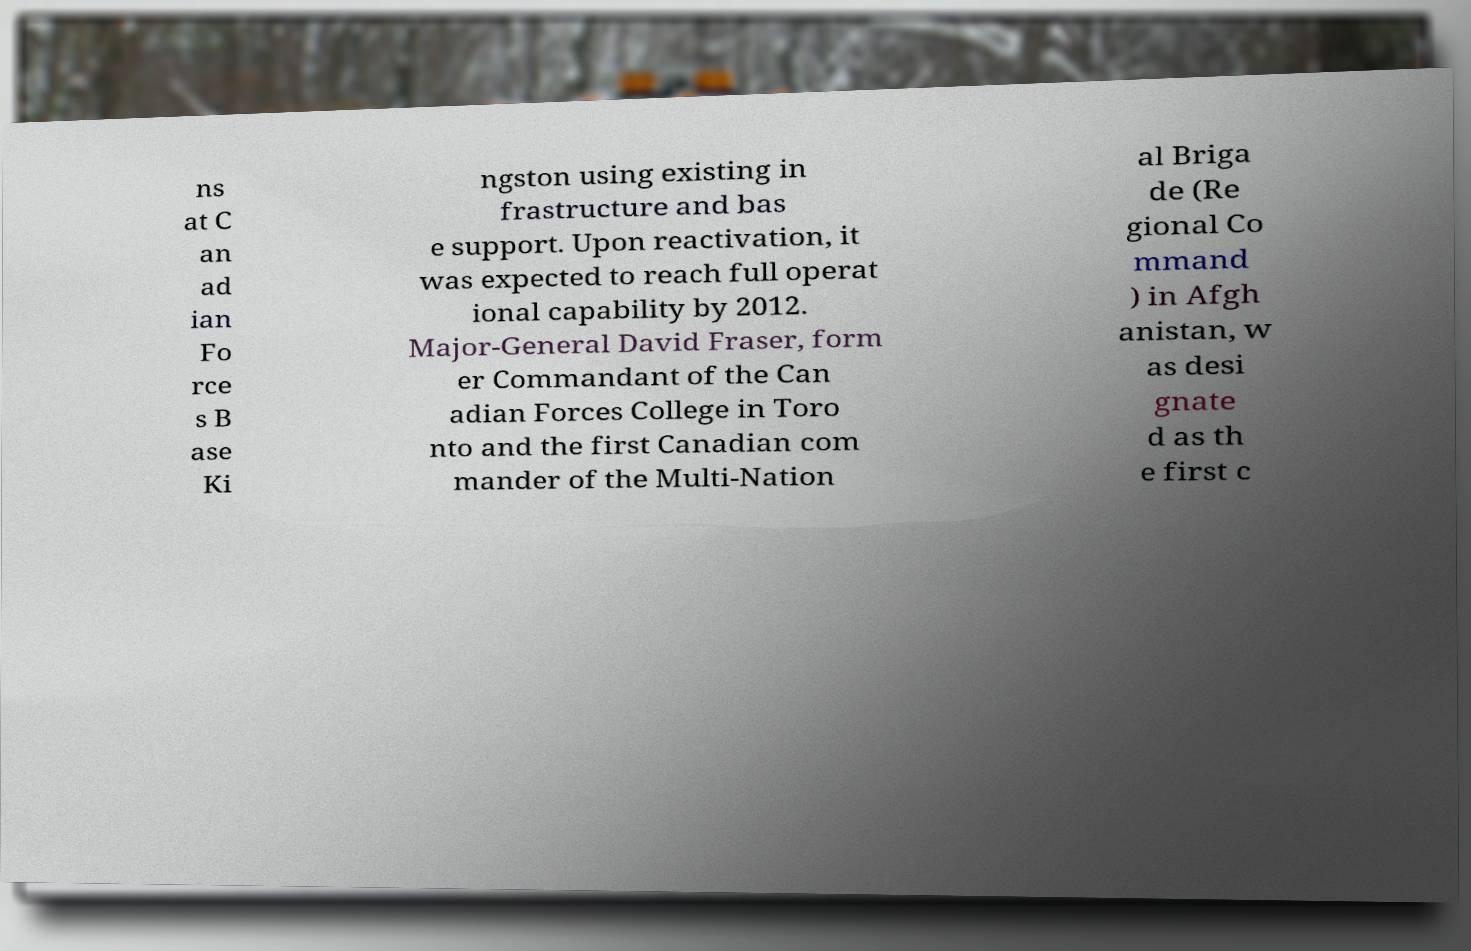For documentation purposes, I need the text within this image transcribed. Could you provide that? ns at C an ad ian Fo rce s B ase Ki ngston using existing in frastructure and bas e support. Upon reactivation, it was expected to reach full operat ional capability by 2012. Major-General David Fraser, form er Commandant of the Can adian Forces College in Toro nto and the first Canadian com mander of the Multi-Nation al Briga de (Re gional Co mmand ) in Afgh anistan, w as desi gnate d as th e first c 